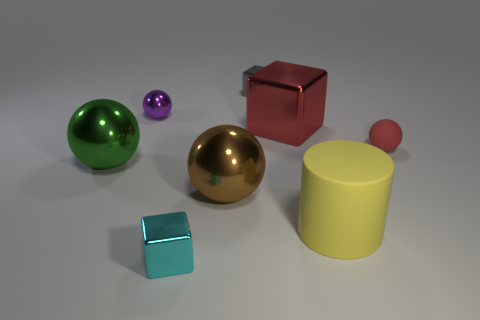Subtract 1 spheres. How many spheres are left? 3 Add 1 large brown shiny objects. How many objects exist? 9 Subtract all cylinders. How many objects are left? 7 Subtract all large green metallic objects. Subtract all big yellow matte cylinders. How many objects are left? 6 Add 5 red spheres. How many red spheres are left? 6 Add 2 metal spheres. How many metal spheres exist? 5 Subtract 0 green blocks. How many objects are left? 8 